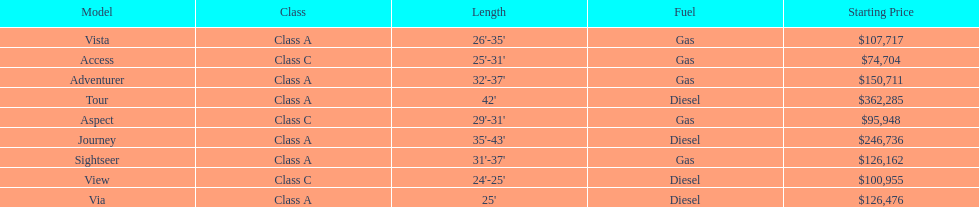What is the name of the top priced winnebago model? Tour. 